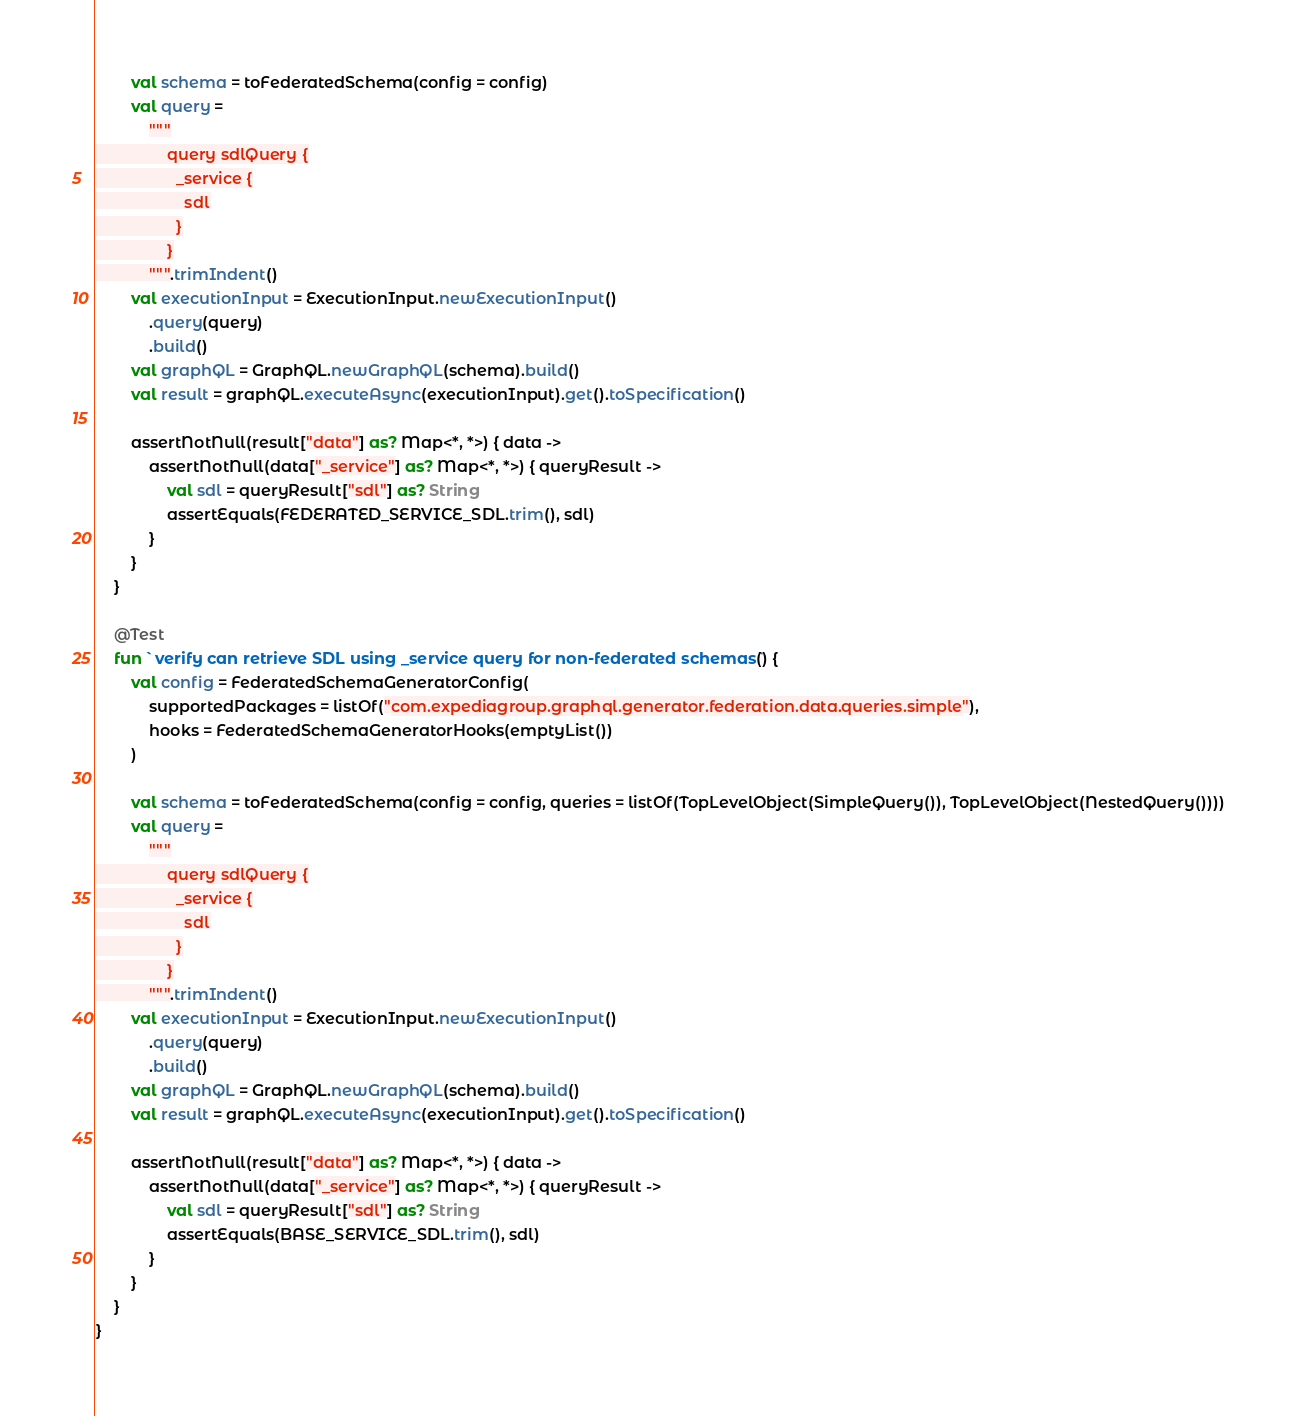Convert code to text. <code><loc_0><loc_0><loc_500><loc_500><_Kotlin_>        val schema = toFederatedSchema(config = config)
        val query =
            """
                query sdlQuery {
                  _service {
                    sdl
                  }
                }
            """.trimIndent()
        val executionInput = ExecutionInput.newExecutionInput()
            .query(query)
            .build()
        val graphQL = GraphQL.newGraphQL(schema).build()
        val result = graphQL.executeAsync(executionInput).get().toSpecification()

        assertNotNull(result["data"] as? Map<*, *>) { data ->
            assertNotNull(data["_service"] as? Map<*, *>) { queryResult ->
                val sdl = queryResult["sdl"] as? String
                assertEquals(FEDERATED_SERVICE_SDL.trim(), sdl)
            }
        }
    }

    @Test
    fun `verify can retrieve SDL using _service query for non-federated schemas`() {
        val config = FederatedSchemaGeneratorConfig(
            supportedPackages = listOf("com.expediagroup.graphql.generator.federation.data.queries.simple"),
            hooks = FederatedSchemaGeneratorHooks(emptyList())
        )

        val schema = toFederatedSchema(config = config, queries = listOf(TopLevelObject(SimpleQuery()), TopLevelObject(NestedQuery())))
        val query =
            """
                query sdlQuery {
                  _service {
                    sdl
                  }
                }
            """.trimIndent()
        val executionInput = ExecutionInput.newExecutionInput()
            .query(query)
            .build()
        val graphQL = GraphQL.newGraphQL(schema).build()
        val result = graphQL.executeAsync(executionInput).get().toSpecification()

        assertNotNull(result["data"] as? Map<*, *>) { data ->
            assertNotNull(data["_service"] as? Map<*, *>) { queryResult ->
                val sdl = queryResult["sdl"] as? String
                assertEquals(BASE_SERVICE_SDL.trim(), sdl)
            }
        }
    }
}
</code> 